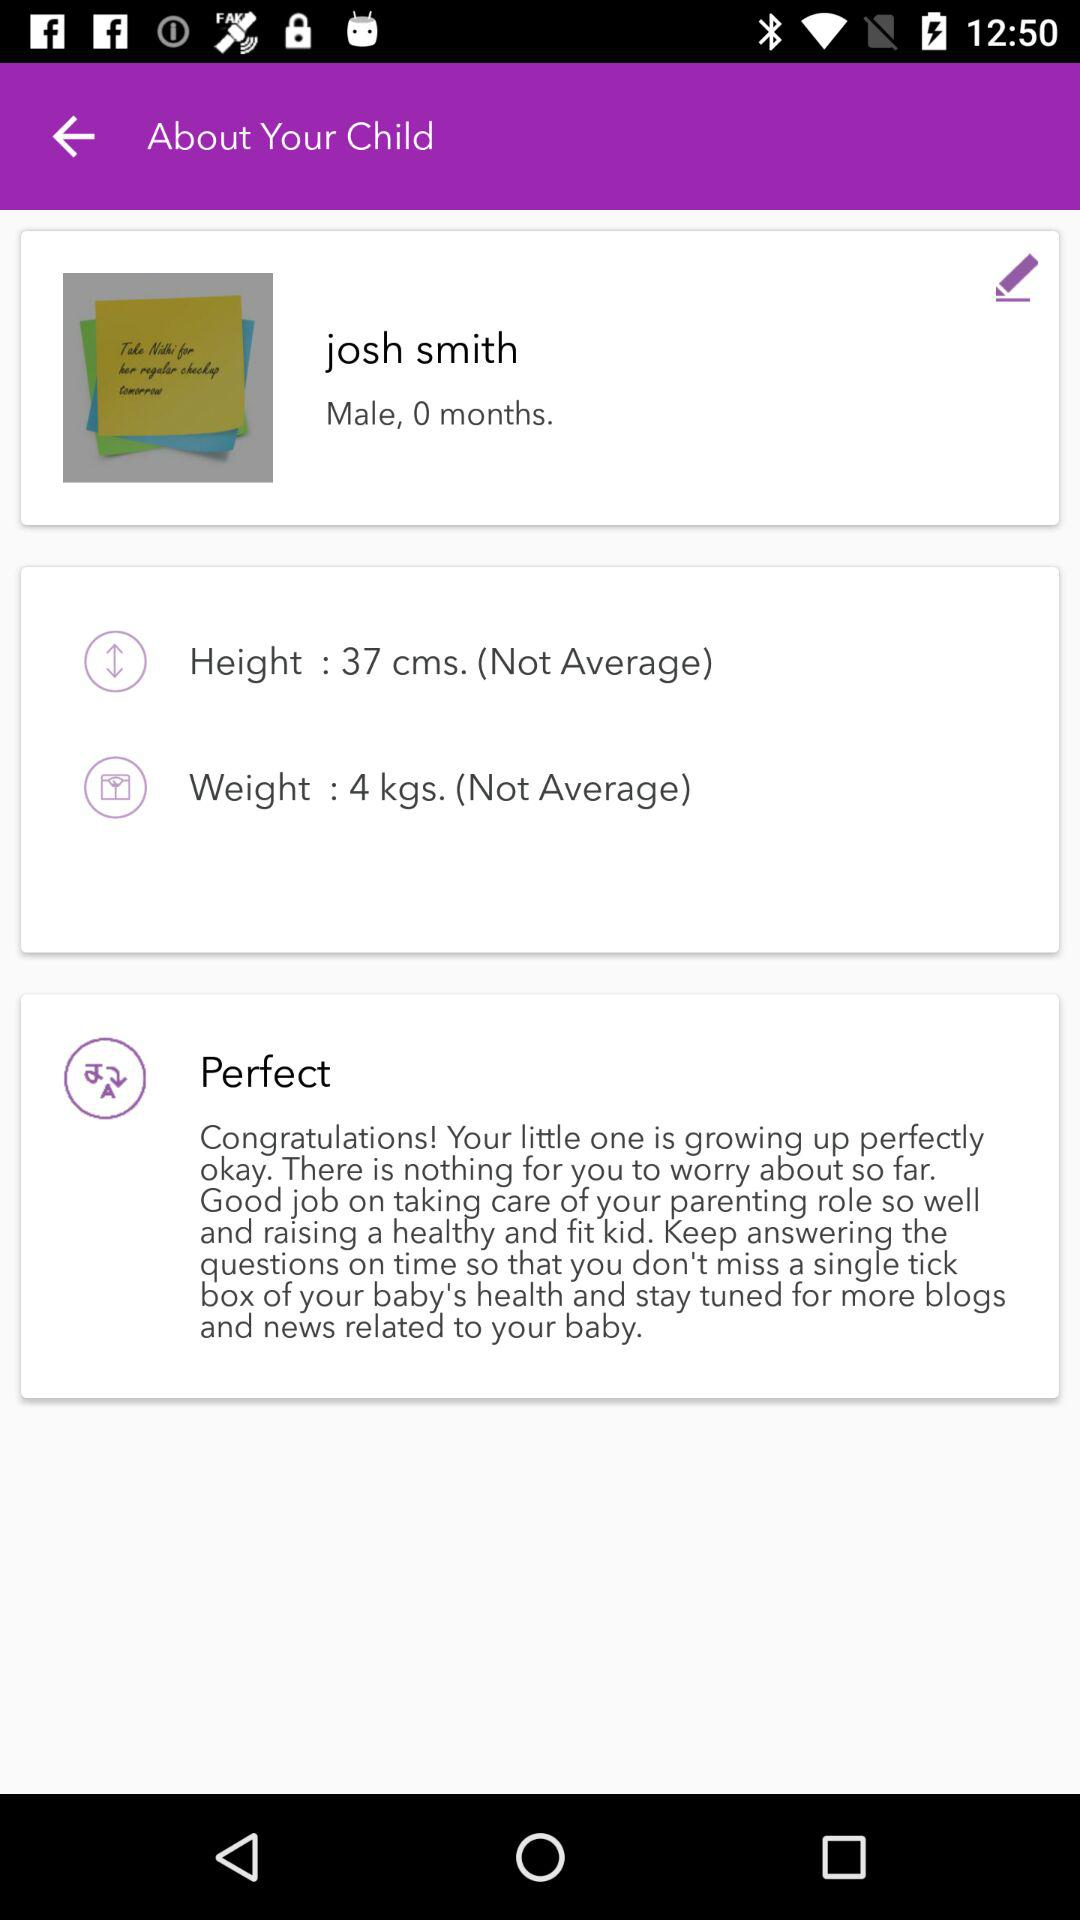What's the weight? The weight is 4 kilograms. 